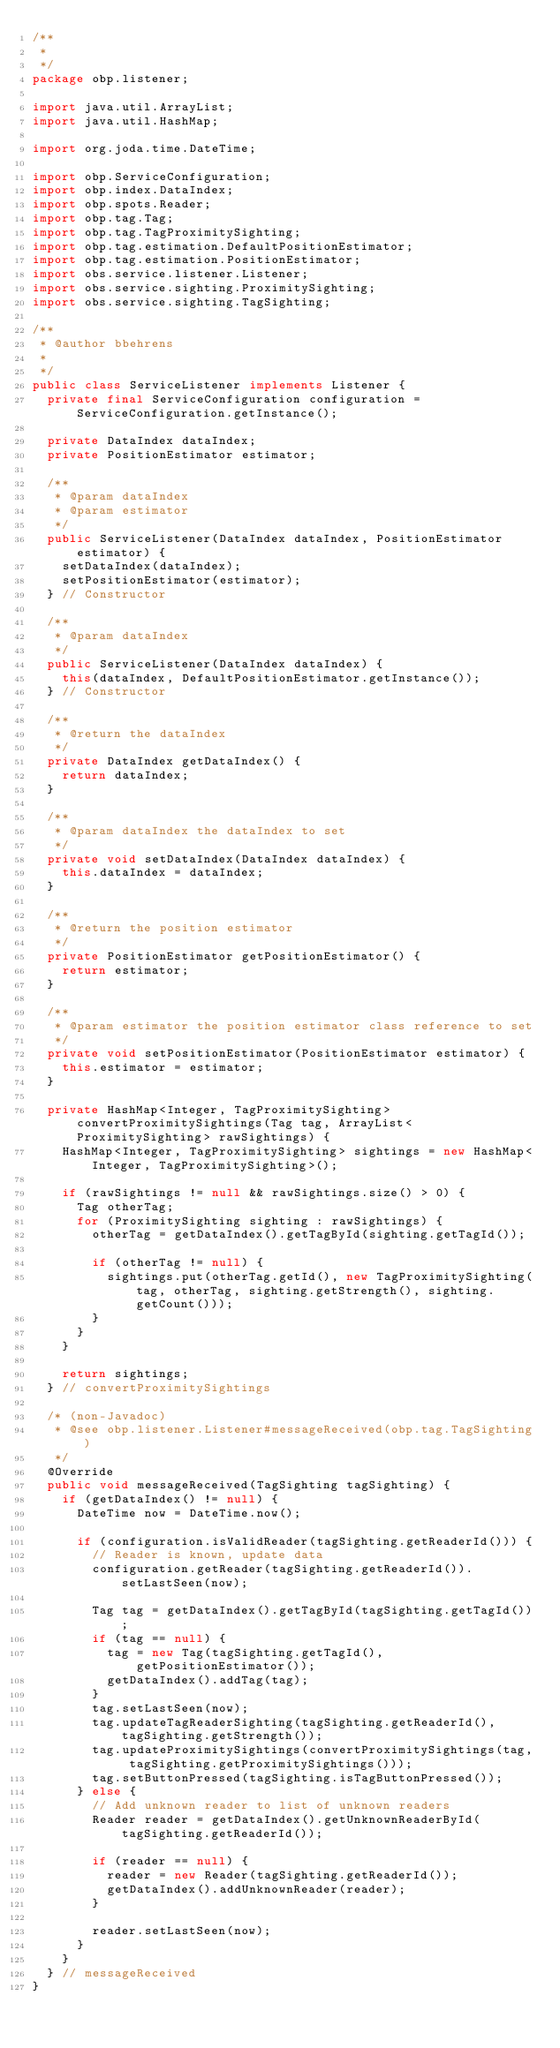<code> <loc_0><loc_0><loc_500><loc_500><_Java_>/**
 * 
 */
package obp.listener;

import java.util.ArrayList;
import java.util.HashMap;

import org.joda.time.DateTime;

import obp.ServiceConfiguration;
import obp.index.DataIndex;
import obp.spots.Reader;
import obp.tag.Tag;
import obp.tag.TagProximitySighting;
import obp.tag.estimation.DefaultPositionEstimator;
import obp.tag.estimation.PositionEstimator;
import obs.service.listener.Listener;
import obs.service.sighting.ProximitySighting;
import obs.service.sighting.TagSighting;

/**
 * @author bbehrens
 *
 */
public class ServiceListener implements Listener {
	private final ServiceConfiguration configuration = ServiceConfiguration.getInstance();
	
	private DataIndex dataIndex;
	private PositionEstimator estimator;
	
	/**
	 * @param dataIndex
	 * @param estimator
	 */
	public ServiceListener(DataIndex dataIndex, PositionEstimator estimator) {
		setDataIndex(dataIndex);
		setPositionEstimator(estimator);
	} // Constructor
	
	/**
	 * @param dataIndex
	 */
	public ServiceListener(DataIndex dataIndex) {
		this(dataIndex, DefaultPositionEstimator.getInstance());
	} // Constructor

	/**
	 * @return the dataIndex
	 */
	private DataIndex getDataIndex() {
		return dataIndex;
	}
	
	/**
	 * @param dataIndex the dataIndex to set
	 */
	private void setDataIndex(DataIndex dataIndex) {
		this.dataIndex = dataIndex;
	}
	
	/**
	 * @return the position estimator
	 */
	private PositionEstimator getPositionEstimator() {
		return estimator;
	}
	
	/**
	 * @param estimator the position estimator class reference to set
	 */
	private void setPositionEstimator(PositionEstimator estimator) {
		this.estimator = estimator;
	}
	
	private HashMap<Integer, TagProximitySighting> convertProximitySightings(Tag tag, ArrayList<ProximitySighting> rawSightings) {
		HashMap<Integer, TagProximitySighting> sightings = new HashMap<Integer, TagProximitySighting>();
		
		if (rawSightings != null && rawSightings.size() > 0) {
			Tag otherTag;
			for (ProximitySighting sighting : rawSightings) {
				otherTag = getDataIndex().getTagById(sighting.getTagId());
				
				if (otherTag != null) {
					sightings.put(otherTag.getId(), new TagProximitySighting(tag, otherTag, sighting.getStrength(), sighting.getCount()));
				}
			}
		}
		
		return sightings;
	} // convertProximitySightings

	/* (non-Javadoc)
	 * @see obp.listener.Listener#messageReceived(obp.tag.TagSighting)
	 */
	@Override
	public void messageReceived(TagSighting tagSighting) {
		if (getDataIndex() != null) {
			DateTime now = DateTime.now();
			
			if (configuration.isValidReader(tagSighting.getReaderId())) {
				// Reader is known, update data
				configuration.getReader(tagSighting.getReaderId()).setLastSeen(now);
				
				Tag tag = getDataIndex().getTagById(tagSighting.getTagId());
				if (tag == null) {
					tag = new Tag(tagSighting.getTagId(), getPositionEstimator());
					getDataIndex().addTag(tag);
				}
				tag.setLastSeen(now);
				tag.updateTagReaderSighting(tagSighting.getReaderId(), tagSighting.getStrength());
				tag.updateProximitySightings(convertProximitySightings(tag, tagSighting.getProximitySightings()));
				tag.setButtonPressed(tagSighting.isTagButtonPressed());
			} else {
				// Add unknown reader to list of unknown readers
				Reader reader = getDataIndex().getUnknownReaderById(tagSighting.getReaderId());
			
				if (reader == null) {
					reader = new Reader(tagSighting.getReaderId());
					getDataIndex().addUnknownReader(reader);
				}
			
				reader.setLastSeen(now);
			}
		}
	} // messageReceived
}</code> 